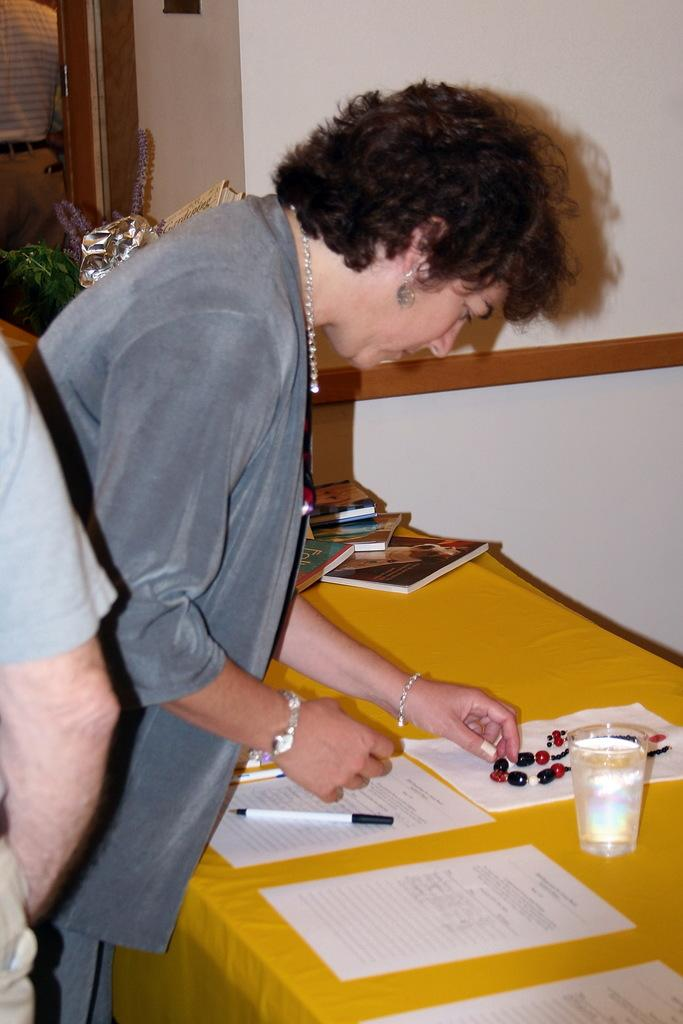What is the main subject in the image? There is a person standing in the image. What objects are on the table in the image? There are papers, a glass, a pen, and books on the table in the image. What can be seen in the background of the image? There is a wall visible in the background. What type of ring is the person wearing in the image? There is no ring visible on the person in the image. What verse is written on the wall in the image? There is no verse written on the wall in the image; only the wall itself is visible in the background. 